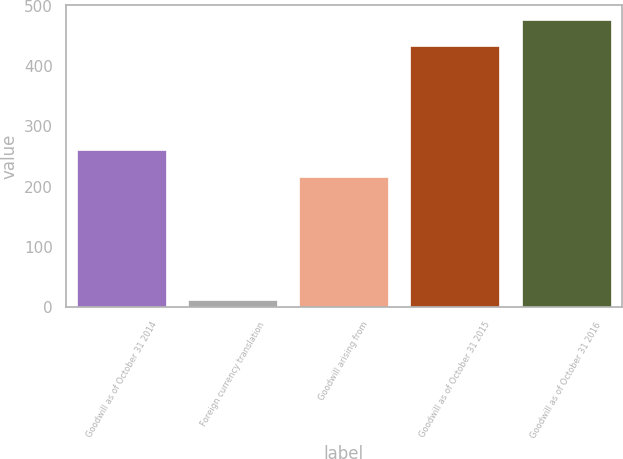Convert chart to OTSL. <chart><loc_0><loc_0><loc_500><loc_500><bar_chart><fcel>Goodwill as of October 31 2014<fcel>Foreign currency translation<fcel>Goodwill arising from<fcel>Goodwill as of October 31 2015<fcel>Goodwill as of October 31 2016<nl><fcel>260.4<fcel>12<fcel>216<fcel>433<fcel>477.4<nl></chart> 